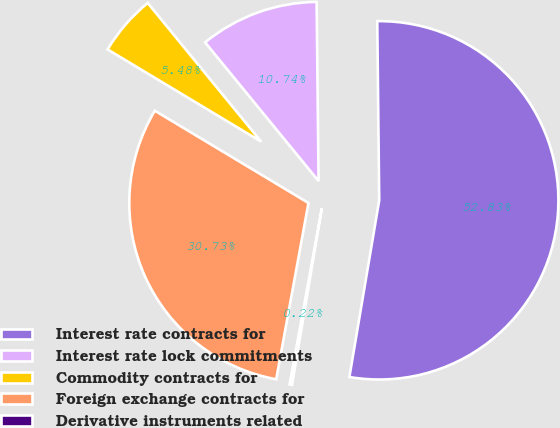Convert chart to OTSL. <chart><loc_0><loc_0><loc_500><loc_500><pie_chart><fcel>Interest rate contracts for<fcel>Interest rate lock commitments<fcel>Commodity contracts for<fcel>Foreign exchange contracts for<fcel>Derivative instruments related<nl><fcel>52.84%<fcel>10.74%<fcel>5.48%<fcel>30.73%<fcel>0.22%<nl></chart> 